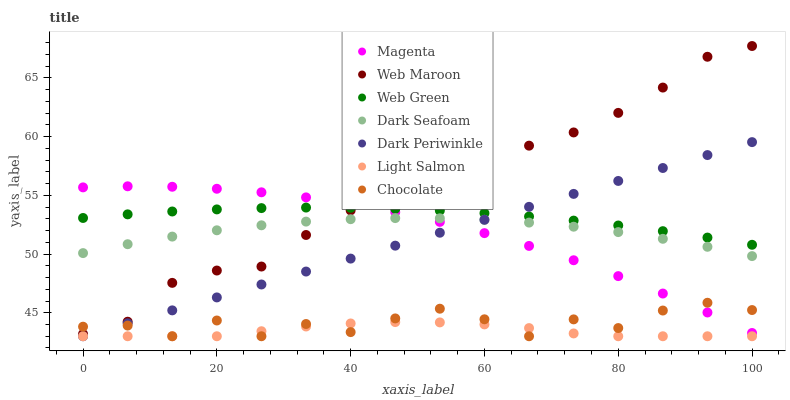Does Light Salmon have the minimum area under the curve?
Answer yes or no. Yes. Does Web Maroon have the maximum area under the curve?
Answer yes or no. Yes. Does Web Green have the minimum area under the curve?
Answer yes or no. No. Does Web Green have the maximum area under the curve?
Answer yes or no. No. Is Dark Periwinkle the smoothest?
Answer yes or no. Yes. Is Chocolate the roughest?
Answer yes or no. Yes. Is Web Maroon the smoothest?
Answer yes or no. No. Is Web Maroon the roughest?
Answer yes or no. No. Does Light Salmon have the lowest value?
Answer yes or no. Yes. Does Web Maroon have the lowest value?
Answer yes or no. No. Does Web Maroon have the highest value?
Answer yes or no. Yes. Does Web Green have the highest value?
Answer yes or no. No. Is Light Salmon less than Magenta?
Answer yes or no. Yes. Is Web Maroon greater than Dark Periwinkle?
Answer yes or no. Yes. Does Dark Seafoam intersect Magenta?
Answer yes or no. Yes. Is Dark Seafoam less than Magenta?
Answer yes or no. No. Is Dark Seafoam greater than Magenta?
Answer yes or no. No. Does Light Salmon intersect Magenta?
Answer yes or no. No. 